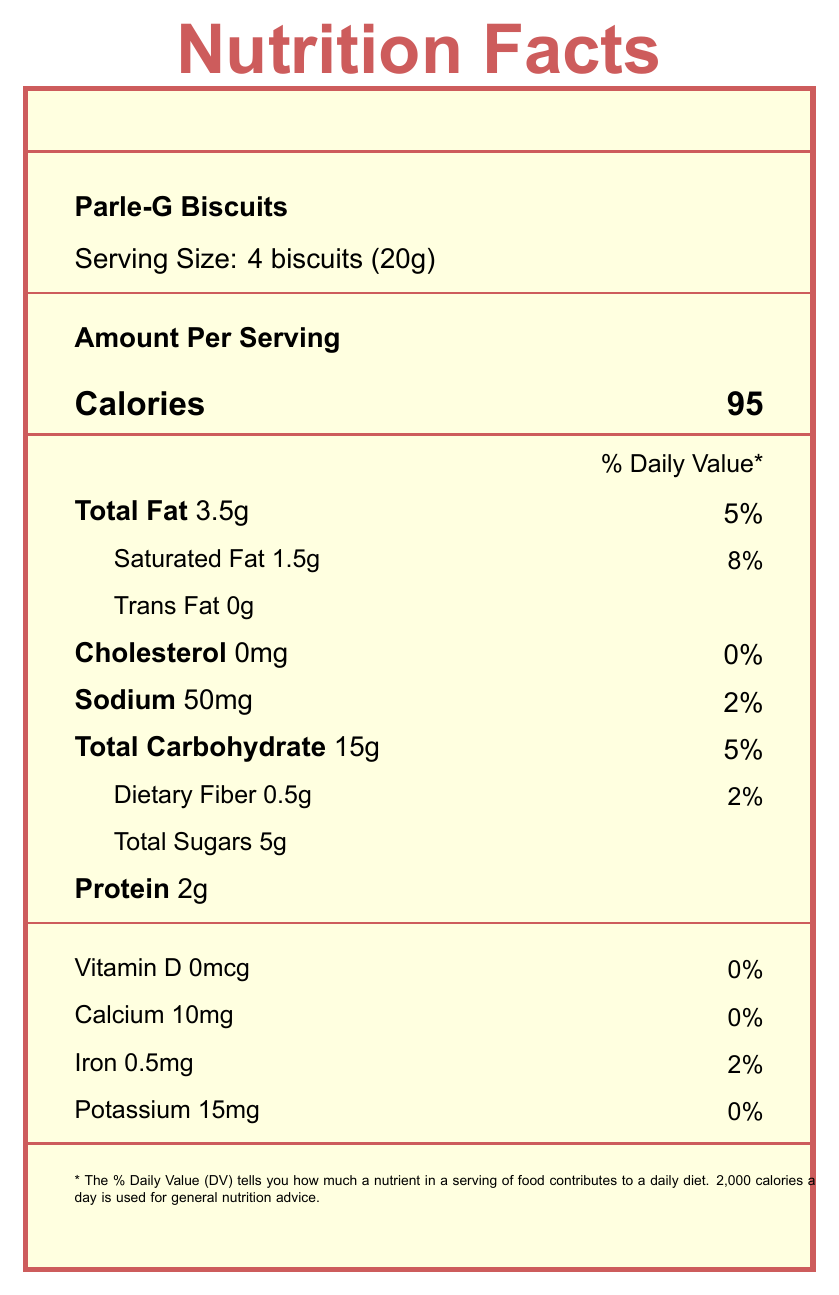what is the calorie content of a serving of Parle-G Biscuits? The document specifies that one serving size (4 biscuits or 20g) of Parle-G Biscuits contains 95 calories.
Answer: 95 calories how much dietary fiber does Haldiram's Aloo Bhujia contain per serving? Haldiram's Aloo Bhujia contains 2 grams of dietary fiber per serving size of 1/2 cup (30g).
Answer: 2 grams what is the sodium content in a serving of Kurkure Masala Munch? The sodium content of Kurkure Masala Munch per serving (1 packet or 30g) is listed as 230mg.
Answer: 230 milligrams what are the total sugars in a serving of Frooti Mango Drink? The document indicates that a serving size of Frooti Mango Drink (1 tetra pack or 200ml) contains 28 grams of total sugars.
Answer: 28 grams which snack provides the highest amount of protein per serving? The document shows that Chikki (Peanut Brittle) contains 5 grams of protein per serving size of 2 pieces (30g), which is higher than the other snacks listed.
Answer: Chikki (Peanut Brittle) which of the following snacks has the least amount of dietary fiber per serving? A. Parle-G Biscuits B. Kurkure Masala Munch C. Haldiram's Aloo Bhujia D. Frooti Mango Drink Frooti Mango Drink contains 0 grams of dietary fiber per serving, which is less than Parle-G Biscuits (0.5g), Kurkure Masala Munch (1g), and Haldiram's Aloo Bhujia (2g).
Answer: D. Frooti Mango Drink which snack has the highest total carbohydrate content per serving? A. Parle-G Biscuits B. Kurkure Masala Munch C. Haldiram's Aloo Bhujia D. Frooti Mango Drink Frooti Mango Drink contains 30 grams of total carbohydrates per serving, which is higher than Parle-G Biscuits (15g), Kurkure Masala Munch (16g), and Haldiram's Aloo Bhujia (15g).
Answer: D. Frooti Mango Drink is the Chikki (Peanut Brittle) a low-sodium snack? Chikki (Peanut Brittle) contains only 5 milligrams of sodium per serving, which is comparatively low.
Answer: Yes summarize the nutritional content of Parle-G Biscuits. This summary covers the main nutritional elements of Parle-G Biscuits, detailing calories, macronutrients, and key micronutrients per serving.
Answer: Parle-G Biscuits provide 95 calories per serving (4 biscuits, 20g), with 3.5g of total fat, 1.5g saturated fat, 0g trans fat, 0mg cholesterol, 50mg sodium, 15g total carbohydrates, 0.5g dietary fiber, 5g total sugars, 2g protein. It also contains small amounts of calcium, iron, and potassium. how much iron does Kurkure Masala Munch contain per serving? Kurkure Masala Munch contains 0.5mg of iron per serving (1 packet, 30g), as specified in the document.
Answer: 0.5 milligrams what percentage of daily value for saturated fat does Haldiram's Aloo Bhujia provide per serving? The document shows that Haldiram's Aloo Bhujia contains 5 grams of saturated fat per serving, which represents 25% of the daily value.
Answer: 25% which snack contains the highest amount of potassium? Haldiram's Aloo Bhujia provides 100 milligrams of potassium per serving, which is the highest compared to the other snacks listed.
Answer: Haldiram's Aloo Bhujia are there any respiratory benefits mentioned for any of the snacks? The document provides nutritional content but does not mention any respiratory benefits for the snacks.
Answer: Cannot be determined is there a healthier snack alternative suggested in the document? The document lists healthier alternatives including roasted chana (chickpeas), fresh fruit slices, and homemade makhana (fox nuts).
Answer: Yes 